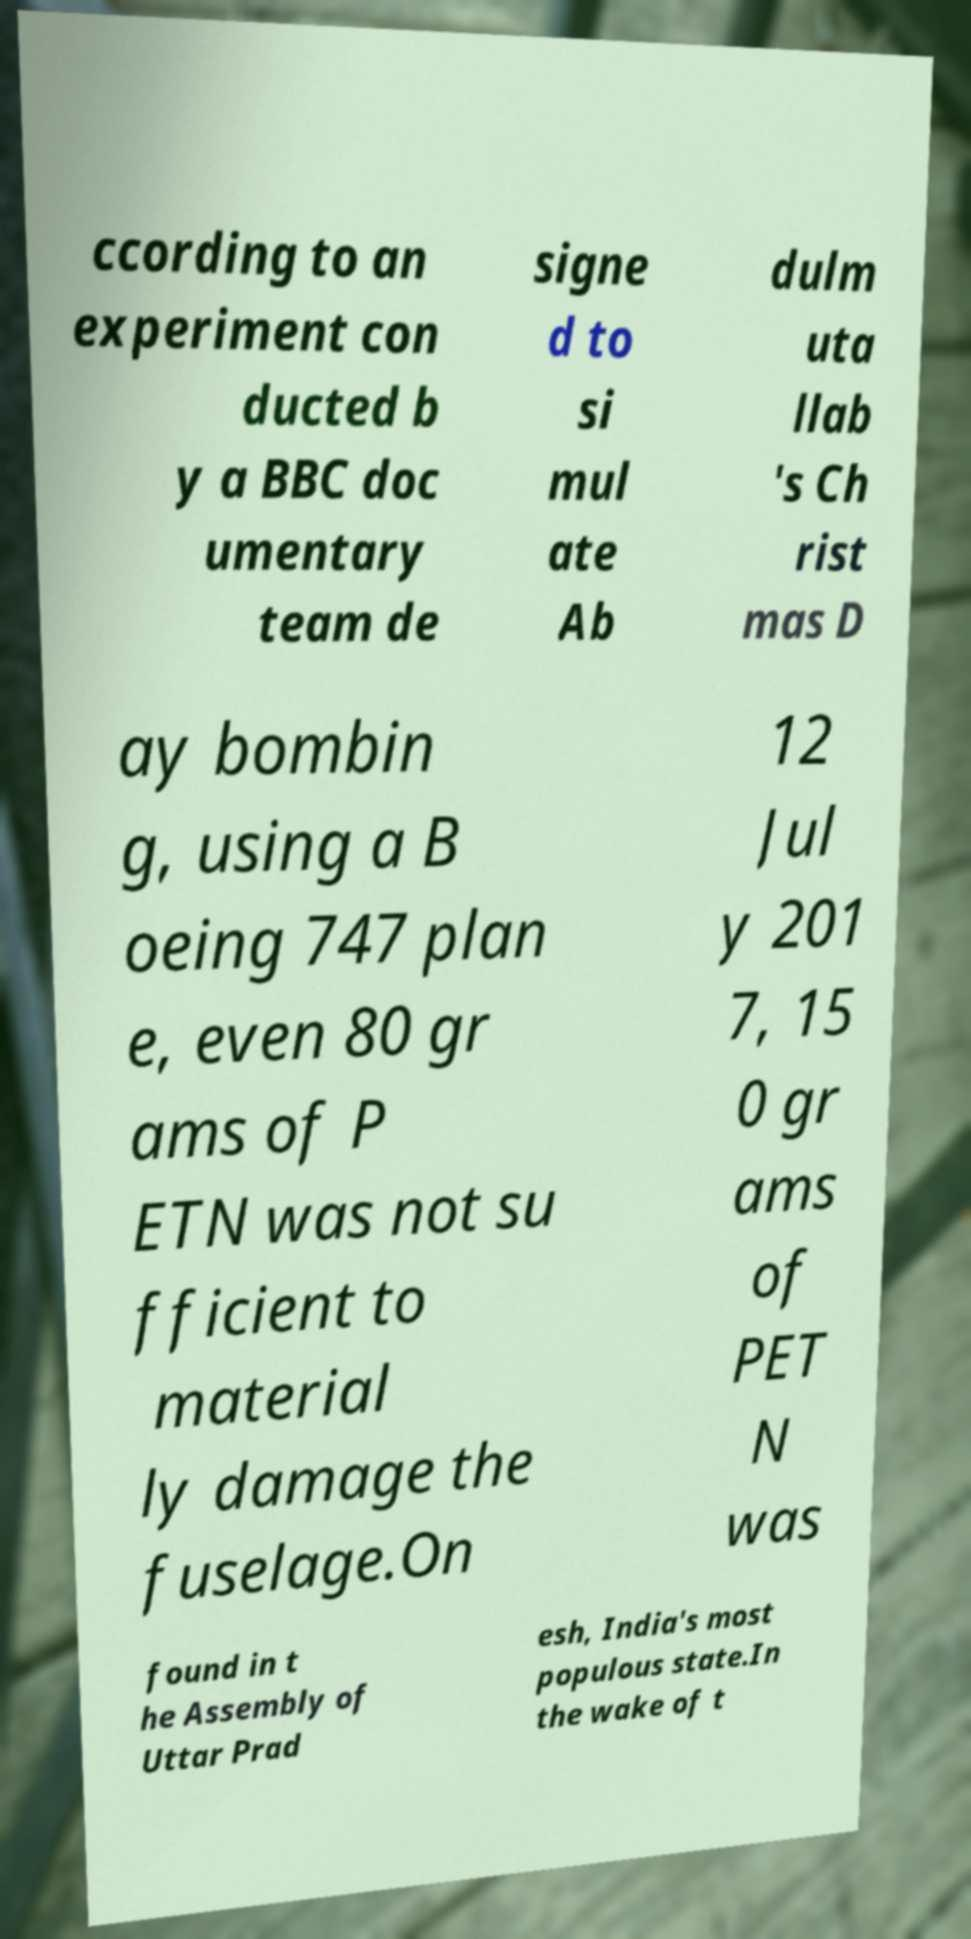Can you read and provide the text displayed in the image?This photo seems to have some interesting text. Can you extract and type it out for me? ccording to an experiment con ducted b y a BBC doc umentary team de signe d to si mul ate Ab dulm uta llab 's Ch rist mas D ay bombin g, using a B oeing 747 plan e, even 80 gr ams of P ETN was not su fficient to material ly damage the fuselage.On 12 Jul y 201 7, 15 0 gr ams of PET N was found in t he Assembly of Uttar Prad esh, India's most populous state.In the wake of t 